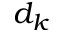Convert formula to latex. <formula><loc_0><loc_0><loc_500><loc_500>d _ { k }</formula> 